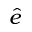<formula> <loc_0><loc_0><loc_500><loc_500>\hat { e }</formula> 